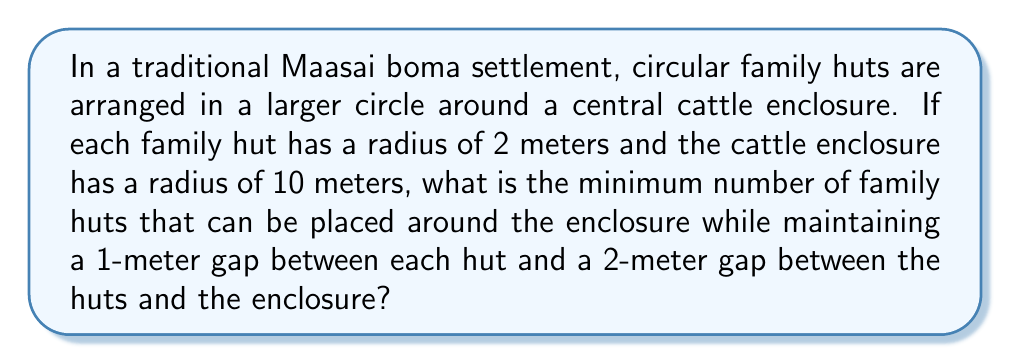Solve this math problem. Let's approach this step-by-step:

1) First, we need to calculate the circumference of the circle on which the centers of the family huts will be placed. This circle has a radius equal to the radius of the cattle enclosure plus the gap between the enclosure and the huts plus the radius of a family hut:

   $R = 10 + 2 + 2 = 14$ meters

2) The circumference of this circle is:

   $C = 2\pi R = 2\pi(14) \approx 87.96$ meters

3) Now, we need to determine how much space each hut occupies along this circumference. Each hut has a diameter of 4 meters (2 * 2m radius) plus the 1-meter gap on each side:

   $S = 4 + 1 + 1 = 6$ meters

4) The number of huts that can fit is the circumference divided by the space each hut occupies, rounded down to the nearest whole number:

   $N = \lfloor \frac{C}{S} \rfloor = \lfloor \frac{87.96}{6} \rfloor = \lfloor 14.66 \rfloor = 14$

5) To verify, we can check if 14 huts actually fit:

   $14 * 6 = 84$ meters, which is less than 87.96 meters

6) 15 huts would require $15 * 6 = 90$ meters, which exceeds the available circumference.

Therefore, the minimum number of family huts that can be placed around the enclosure under these conditions is 14.
Answer: 14 huts 